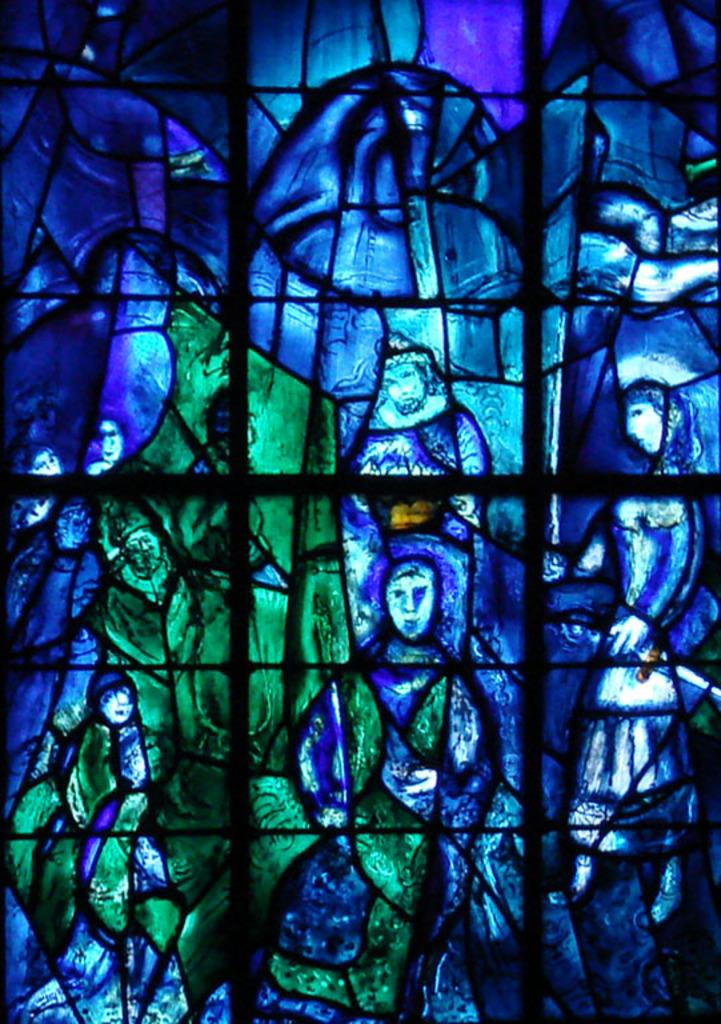What is depicted in the image? There is art in the image. What is the art placed on? The art is on a glass surface. What colors are predominant in the art? The art features blue and green colors. Where is the kitten sitting on the glass surface in the image? There is no kitten present in the image; it only features art on a glass surface. 